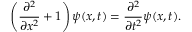Convert formula to latex. <formula><loc_0><loc_0><loc_500><loc_500>\left ( { \frac { \partial ^ { 2 } } { \partial x ^ { 2 } } } + 1 \right ) \psi ( x , t ) = { \frac { \partial ^ { 2 } } { \partial t ^ { 2 } } } \psi ( x , t ) .</formula> 